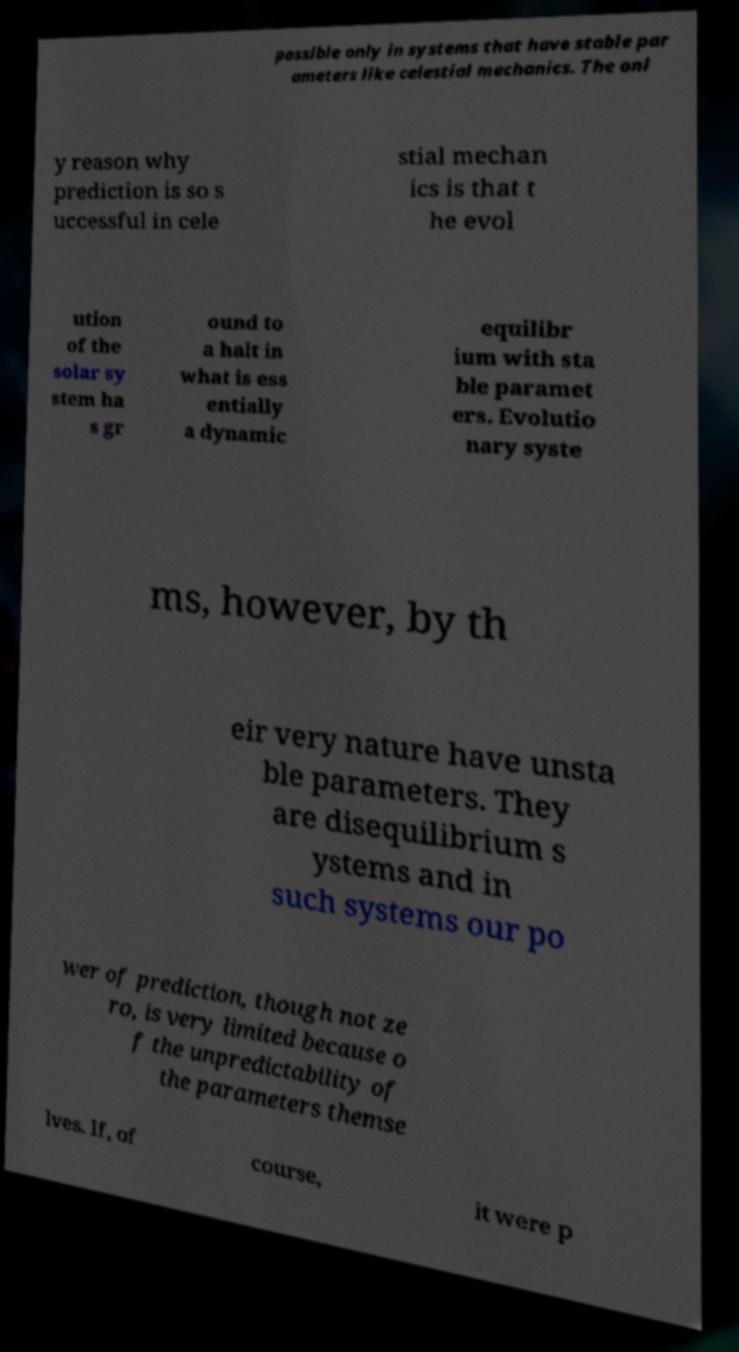Could you extract and type out the text from this image? possible only in systems that have stable par ameters like celestial mechanics. The onl y reason why prediction is so s uccessful in cele stial mechan ics is that t he evol ution of the solar sy stem ha s gr ound to a halt in what is ess entially a dynamic equilibr ium with sta ble paramet ers. Evolutio nary syste ms, however, by th eir very nature have unsta ble parameters. They are disequilibrium s ystems and in such systems our po wer of prediction, though not ze ro, is very limited because o f the unpredictability of the parameters themse lves. If, of course, it were p 